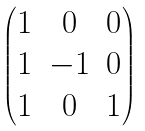<formula> <loc_0><loc_0><loc_500><loc_500>\begin{pmatrix} 1 & 0 & 0 \\ 1 & - 1 & 0 \\ 1 & 0 & 1 \end{pmatrix}</formula> 